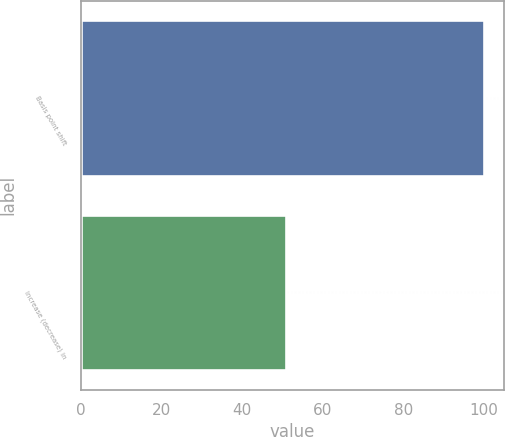<chart> <loc_0><loc_0><loc_500><loc_500><bar_chart><fcel>Basis point shift<fcel>Increase (decrease) in<nl><fcel>100<fcel>51<nl></chart> 